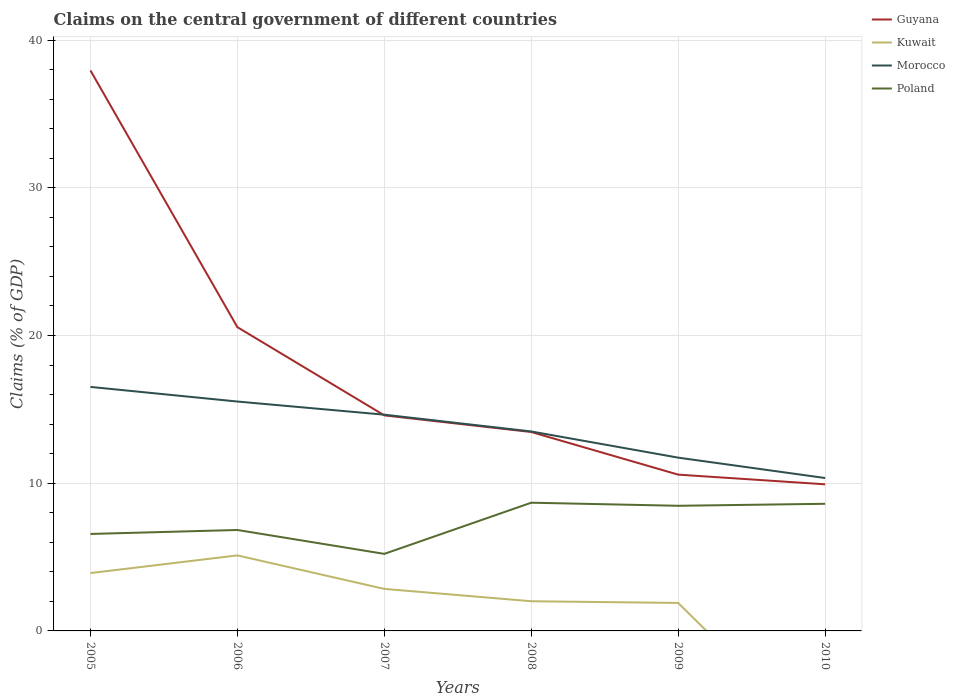Does the line corresponding to Poland intersect with the line corresponding to Guyana?
Make the answer very short. No. Is the number of lines equal to the number of legend labels?
Keep it short and to the point. No. Across all years, what is the maximum percentage of GDP claimed on the central government in Kuwait?
Your answer should be compact. 0. What is the total percentage of GDP claimed on the central government in Poland in the graph?
Provide a succinct answer. -2.04. What is the difference between the highest and the second highest percentage of GDP claimed on the central government in Morocco?
Give a very brief answer. 6.17. What is the difference between the highest and the lowest percentage of GDP claimed on the central government in Poland?
Give a very brief answer. 3. How many years are there in the graph?
Provide a succinct answer. 6. What is the difference between two consecutive major ticks on the Y-axis?
Give a very brief answer. 10. Are the values on the major ticks of Y-axis written in scientific E-notation?
Your response must be concise. No. Does the graph contain any zero values?
Your response must be concise. Yes. Does the graph contain grids?
Your answer should be very brief. Yes. Where does the legend appear in the graph?
Your answer should be very brief. Top right. What is the title of the graph?
Your answer should be compact. Claims on the central government of different countries. What is the label or title of the X-axis?
Offer a very short reply. Years. What is the label or title of the Y-axis?
Offer a very short reply. Claims (% of GDP). What is the Claims (% of GDP) in Guyana in 2005?
Offer a terse response. 37.94. What is the Claims (% of GDP) in Kuwait in 2005?
Your response must be concise. 3.92. What is the Claims (% of GDP) of Morocco in 2005?
Provide a short and direct response. 16.52. What is the Claims (% of GDP) of Poland in 2005?
Provide a succinct answer. 6.56. What is the Claims (% of GDP) of Guyana in 2006?
Make the answer very short. 20.56. What is the Claims (% of GDP) in Kuwait in 2006?
Give a very brief answer. 5.11. What is the Claims (% of GDP) of Morocco in 2006?
Provide a short and direct response. 15.53. What is the Claims (% of GDP) in Poland in 2006?
Your answer should be compact. 6.83. What is the Claims (% of GDP) of Guyana in 2007?
Keep it short and to the point. 14.59. What is the Claims (% of GDP) of Kuwait in 2007?
Your answer should be very brief. 2.84. What is the Claims (% of GDP) of Morocco in 2007?
Keep it short and to the point. 14.64. What is the Claims (% of GDP) of Poland in 2007?
Ensure brevity in your answer.  5.22. What is the Claims (% of GDP) of Guyana in 2008?
Ensure brevity in your answer.  13.47. What is the Claims (% of GDP) in Kuwait in 2008?
Ensure brevity in your answer.  2.01. What is the Claims (% of GDP) of Morocco in 2008?
Your answer should be compact. 13.5. What is the Claims (% of GDP) of Poland in 2008?
Your response must be concise. 8.68. What is the Claims (% of GDP) in Guyana in 2009?
Keep it short and to the point. 10.58. What is the Claims (% of GDP) in Kuwait in 2009?
Your answer should be very brief. 1.89. What is the Claims (% of GDP) of Morocco in 2009?
Provide a short and direct response. 11.73. What is the Claims (% of GDP) in Poland in 2009?
Give a very brief answer. 8.47. What is the Claims (% of GDP) of Guyana in 2010?
Give a very brief answer. 9.93. What is the Claims (% of GDP) in Morocco in 2010?
Make the answer very short. 10.35. What is the Claims (% of GDP) of Poland in 2010?
Your answer should be compact. 8.61. Across all years, what is the maximum Claims (% of GDP) in Guyana?
Your answer should be compact. 37.94. Across all years, what is the maximum Claims (% of GDP) in Kuwait?
Provide a succinct answer. 5.11. Across all years, what is the maximum Claims (% of GDP) of Morocco?
Offer a very short reply. 16.52. Across all years, what is the maximum Claims (% of GDP) in Poland?
Your response must be concise. 8.68. Across all years, what is the minimum Claims (% of GDP) in Guyana?
Give a very brief answer. 9.93. Across all years, what is the minimum Claims (% of GDP) in Kuwait?
Ensure brevity in your answer.  0. Across all years, what is the minimum Claims (% of GDP) in Morocco?
Provide a short and direct response. 10.35. Across all years, what is the minimum Claims (% of GDP) of Poland?
Keep it short and to the point. 5.22. What is the total Claims (% of GDP) of Guyana in the graph?
Provide a short and direct response. 107.07. What is the total Claims (% of GDP) of Kuwait in the graph?
Provide a succinct answer. 15.78. What is the total Claims (% of GDP) in Morocco in the graph?
Your response must be concise. 82.27. What is the total Claims (% of GDP) in Poland in the graph?
Ensure brevity in your answer.  44.37. What is the difference between the Claims (% of GDP) of Guyana in 2005 and that in 2006?
Provide a succinct answer. 17.38. What is the difference between the Claims (% of GDP) of Kuwait in 2005 and that in 2006?
Offer a terse response. -1.2. What is the difference between the Claims (% of GDP) of Morocco in 2005 and that in 2006?
Provide a succinct answer. 0.99. What is the difference between the Claims (% of GDP) in Poland in 2005 and that in 2006?
Provide a short and direct response. -0.27. What is the difference between the Claims (% of GDP) in Guyana in 2005 and that in 2007?
Your answer should be compact. 23.35. What is the difference between the Claims (% of GDP) of Kuwait in 2005 and that in 2007?
Provide a succinct answer. 1.07. What is the difference between the Claims (% of GDP) of Morocco in 2005 and that in 2007?
Provide a short and direct response. 1.88. What is the difference between the Claims (% of GDP) in Poland in 2005 and that in 2007?
Make the answer very short. 1.35. What is the difference between the Claims (% of GDP) in Guyana in 2005 and that in 2008?
Keep it short and to the point. 24.48. What is the difference between the Claims (% of GDP) in Kuwait in 2005 and that in 2008?
Your answer should be compact. 1.91. What is the difference between the Claims (% of GDP) in Morocco in 2005 and that in 2008?
Provide a succinct answer. 3.02. What is the difference between the Claims (% of GDP) in Poland in 2005 and that in 2008?
Give a very brief answer. -2.12. What is the difference between the Claims (% of GDP) of Guyana in 2005 and that in 2009?
Make the answer very short. 27.36. What is the difference between the Claims (% of GDP) of Kuwait in 2005 and that in 2009?
Provide a succinct answer. 2.02. What is the difference between the Claims (% of GDP) in Morocco in 2005 and that in 2009?
Your response must be concise. 4.79. What is the difference between the Claims (% of GDP) in Poland in 2005 and that in 2009?
Your answer should be compact. -1.91. What is the difference between the Claims (% of GDP) in Guyana in 2005 and that in 2010?
Your response must be concise. 28.02. What is the difference between the Claims (% of GDP) in Morocco in 2005 and that in 2010?
Ensure brevity in your answer.  6.17. What is the difference between the Claims (% of GDP) of Poland in 2005 and that in 2010?
Make the answer very short. -2.04. What is the difference between the Claims (% of GDP) of Guyana in 2006 and that in 2007?
Provide a succinct answer. 5.97. What is the difference between the Claims (% of GDP) of Kuwait in 2006 and that in 2007?
Ensure brevity in your answer.  2.27. What is the difference between the Claims (% of GDP) in Morocco in 2006 and that in 2007?
Keep it short and to the point. 0.89. What is the difference between the Claims (% of GDP) of Poland in 2006 and that in 2007?
Make the answer very short. 1.62. What is the difference between the Claims (% of GDP) of Guyana in 2006 and that in 2008?
Offer a terse response. 7.1. What is the difference between the Claims (% of GDP) in Kuwait in 2006 and that in 2008?
Provide a succinct answer. 3.1. What is the difference between the Claims (% of GDP) of Morocco in 2006 and that in 2008?
Your answer should be very brief. 2.03. What is the difference between the Claims (% of GDP) in Poland in 2006 and that in 2008?
Provide a short and direct response. -1.85. What is the difference between the Claims (% of GDP) in Guyana in 2006 and that in 2009?
Provide a succinct answer. 9.98. What is the difference between the Claims (% of GDP) in Kuwait in 2006 and that in 2009?
Offer a terse response. 3.22. What is the difference between the Claims (% of GDP) of Morocco in 2006 and that in 2009?
Give a very brief answer. 3.8. What is the difference between the Claims (% of GDP) in Poland in 2006 and that in 2009?
Offer a terse response. -1.64. What is the difference between the Claims (% of GDP) in Guyana in 2006 and that in 2010?
Keep it short and to the point. 10.64. What is the difference between the Claims (% of GDP) of Morocco in 2006 and that in 2010?
Provide a short and direct response. 5.18. What is the difference between the Claims (% of GDP) of Poland in 2006 and that in 2010?
Your answer should be very brief. -1.77. What is the difference between the Claims (% of GDP) of Guyana in 2007 and that in 2008?
Keep it short and to the point. 1.13. What is the difference between the Claims (% of GDP) of Kuwait in 2007 and that in 2008?
Your response must be concise. 0.84. What is the difference between the Claims (% of GDP) of Morocco in 2007 and that in 2008?
Offer a terse response. 1.14. What is the difference between the Claims (% of GDP) in Poland in 2007 and that in 2008?
Make the answer very short. -3.46. What is the difference between the Claims (% of GDP) of Guyana in 2007 and that in 2009?
Your answer should be very brief. 4.01. What is the difference between the Claims (% of GDP) in Kuwait in 2007 and that in 2009?
Offer a very short reply. 0.95. What is the difference between the Claims (% of GDP) in Morocco in 2007 and that in 2009?
Your answer should be very brief. 2.91. What is the difference between the Claims (% of GDP) of Poland in 2007 and that in 2009?
Keep it short and to the point. -3.26. What is the difference between the Claims (% of GDP) of Guyana in 2007 and that in 2010?
Keep it short and to the point. 4.67. What is the difference between the Claims (% of GDP) of Morocco in 2007 and that in 2010?
Keep it short and to the point. 4.29. What is the difference between the Claims (% of GDP) in Poland in 2007 and that in 2010?
Give a very brief answer. -3.39. What is the difference between the Claims (% of GDP) of Guyana in 2008 and that in 2009?
Provide a short and direct response. 2.89. What is the difference between the Claims (% of GDP) in Kuwait in 2008 and that in 2009?
Provide a short and direct response. 0.11. What is the difference between the Claims (% of GDP) of Morocco in 2008 and that in 2009?
Offer a very short reply. 1.77. What is the difference between the Claims (% of GDP) in Poland in 2008 and that in 2009?
Ensure brevity in your answer.  0.21. What is the difference between the Claims (% of GDP) in Guyana in 2008 and that in 2010?
Provide a succinct answer. 3.54. What is the difference between the Claims (% of GDP) of Morocco in 2008 and that in 2010?
Give a very brief answer. 3.15. What is the difference between the Claims (% of GDP) of Poland in 2008 and that in 2010?
Provide a succinct answer. 0.07. What is the difference between the Claims (% of GDP) in Guyana in 2009 and that in 2010?
Make the answer very short. 0.65. What is the difference between the Claims (% of GDP) of Morocco in 2009 and that in 2010?
Provide a succinct answer. 1.38. What is the difference between the Claims (% of GDP) of Poland in 2009 and that in 2010?
Your answer should be very brief. -0.13. What is the difference between the Claims (% of GDP) in Guyana in 2005 and the Claims (% of GDP) in Kuwait in 2006?
Keep it short and to the point. 32.83. What is the difference between the Claims (% of GDP) of Guyana in 2005 and the Claims (% of GDP) of Morocco in 2006?
Offer a very short reply. 22.41. What is the difference between the Claims (% of GDP) of Guyana in 2005 and the Claims (% of GDP) of Poland in 2006?
Give a very brief answer. 31.11. What is the difference between the Claims (% of GDP) of Kuwait in 2005 and the Claims (% of GDP) of Morocco in 2006?
Provide a short and direct response. -11.61. What is the difference between the Claims (% of GDP) in Kuwait in 2005 and the Claims (% of GDP) in Poland in 2006?
Your answer should be very brief. -2.92. What is the difference between the Claims (% of GDP) in Morocco in 2005 and the Claims (% of GDP) in Poland in 2006?
Provide a succinct answer. 9.69. What is the difference between the Claims (% of GDP) in Guyana in 2005 and the Claims (% of GDP) in Kuwait in 2007?
Your answer should be compact. 35.1. What is the difference between the Claims (% of GDP) in Guyana in 2005 and the Claims (% of GDP) in Morocco in 2007?
Your answer should be compact. 23.3. What is the difference between the Claims (% of GDP) of Guyana in 2005 and the Claims (% of GDP) of Poland in 2007?
Your answer should be very brief. 32.73. What is the difference between the Claims (% of GDP) in Kuwait in 2005 and the Claims (% of GDP) in Morocco in 2007?
Your answer should be compact. -10.72. What is the difference between the Claims (% of GDP) of Kuwait in 2005 and the Claims (% of GDP) of Poland in 2007?
Your answer should be very brief. -1.3. What is the difference between the Claims (% of GDP) in Morocco in 2005 and the Claims (% of GDP) in Poland in 2007?
Give a very brief answer. 11.3. What is the difference between the Claims (% of GDP) of Guyana in 2005 and the Claims (% of GDP) of Kuwait in 2008?
Offer a very short reply. 35.93. What is the difference between the Claims (% of GDP) of Guyana in 2005 and the Claims (% of GDP) of Morocco in 2008?
Offer a very short reply. 24.44. What is the difference between the Claims (% of GDP) of Guyana in 2005 and the Claims (% of GDP) of Poland in 2008?
Provide a succinct answer. 29.26. What is the difference between the Claims (% of GDP) in Kuwait in 2005 and the Claims (% of GDP) in Morocco in 2008?
Your response must be concise. -9.59. What is the difference between the Claims (% of GDP) in Kuwait in 2005 and the Claims (% of GDP) in Poland in 2008?
Your response must be concise. -4.76. What is the difference between the Claims (% of GDP) in Morocco in 2005 and the Claims (% of GDP) in Poland in 2008?
Make the answer very short. 7.84. What is the difference between the Claims (% of GDP) in Guyana in 2005 and the Claims (% of GDP) in Kuwait in 2009?
Offer a very short reply. 36.05. What is the difference between the Claims (% of GDP) of Guyana in 2005 and the Claims (% of GDP) of Morocco in 2009?
Your answer should be very brief. 26.21. What is the difference between the Claims (% of GDP) of Guyana in 2005 and the Claims (% of GDP) of Poland in 2009?
Ensure brevity in your answer.  29.47. What is the difference between the Claims (% of GDP) in Kuwait in 2005 and the Claims (% of GDP) in Morocco in 2009?
Provide a short and direct response. -7.81. What is the difference between the Claims (% of GDP) in Kuwait in 2005 and the Claims (% of GDP) in Poland in 2009?
Your answer should be very brief. -4.56. What is the difference between the Claims (% of GDP) in Morocco in 2005 and the Claims (% of GDP) in Poland in 2009?
Offer a terse response. 8.05. What is the difference between the Claims (% of GDP) of Guyana in 2005 and the Claims (% of GDP) of Morocco in 2010?
Keep it short and to the point. 27.59. What is the difference between the Claims (% of GDP) of Guyana in 2005 and the Claims (% of GDP) of Poland in 2010?
Your answer should be very brief. 29.34. What is the difference between the Claims (% of GDP) of Kuwait in 2005 and the Claims (% of GDP) of Morocco in 2010?
Provide a succinct answer. -6.44. What is the difference between the Claims (% of GDP) in Kuwait in 2005 and the Claims (% of GDP) in Poland in 2010?
Keep it short and to the point. -4.69. What is the difference between the Claims (% of GDP) of Morocco in 2005 and the Claims (% of GDP) of Poland in 2010?
Give a very brief answer. 7.91. What is the difference between the Claims (% of GDP) in Guyana in 2006 and the Claims (% of GDP) in Kuwait in 2007?
Ensure brevity in your answer.  17.72. What is the difference between the Claims (% of GDP) in Guyana in 2006 and the Claims (% of GDP) in Morocco in 2007?
Your answer should be very brief. 5.92. What is the difference between the Claims (% of GDP) in Guyana in 2006 and the Claims (% of GDP) in Poland in 2007?
Provide a short and direct response. 15.35. What is the difference between the Claims (% of GDP) in Kuwait in 2006 and the Claims (% of GDP) in Morocco in 2007?
Offer a very short reply. -9.53. What is the difference between the Claims (% of GDP) in Kuwait in 2006 and the Claims (% of GDP) in Poland in 2007?
Your response must be concise. -0.1. What is the difference between the Claims (% of GDP) in Morocco in 2006 and the Claims (% of GDP) in Poland in 2007?
Ensure brevity in your answer.  10.31. What is the difference between the Claims (% of GDP) of Guyana in 2006 and the Claims (% of GDP) of Kuwait in 2008?
Ensure brevity in your answer.  18.55. What is the difference between the Claims (% of GDP) in Guyana in 2006 and the Claims (% of GDP) in Morocco in 2008?
Keep it short and to the point. 7.06. What is the difference between the Claims (% of GDP) of Guyana in 2006 and the Claims (% of GDP) of Poland in 2008?
Provide a short and direct response. 11.88. What is the difference between the Claims (% of GDP) of Kuwait in 2006 and the Claims (% of GDP) of Morocco in 2008?
Ensure brevity in your answer.  -8.39. What is the difference between the Claims (% of GDP) in Kuwait in 2006 and the Claims (% of GDP) in Poland in 2008?
Your answer should be compact. -3.57. What is the difference between the Claims (% of GDP) of Morocco in 2006 and the Claims (% of GDP) of Poland in 2008?
Your answer should be very brief. 6.85. What is the difference between the Claims (% of GDP) in Guyana in 2006 and the Claims (% of GDP) in Kuwait in 2009?
Your answer should be very brief. 18.67. What is the difference between the Claims (% of GDP) of Guyana in 2006 and the Claims (% of GDP) of Morocco in 2009?
Make the answer very short. 8.83. What is the difference between the Claims (% of GDP) of Guyana in 2006 and the Claims (% of GDP) of Poland in 2009?
Keep it short and to the point. 12.09. What is the difference between the Claims (% of GDP) in Kuwait in 2006 and the Claims (% of GDP) in Morocco in 2009?
Make the answer very short. -6.62. What is the difference between the Claims (% of GDP) in Kuwait in 2006 and the Claims (% of GDP) in Poland in 2009?
Your answer should be very brief. -3.36. What is the difference between the Claims (% of GDP) of Morocco in 2006 and the Claims (% of GDP) of Poland in 2009?
Ensure brevity in your answer.  7.06. What is the difference between the Claims (% of GDP) in Guyana in 2006 and the Claims (% of GDP) in Morocco in 2010?
Give a very brief answer. 10.21. What is the difference between the Claims (% of GDP) of Guyana in 2006 and the Claims (% of GDP) of Poland in 2010?
Provide a succinct answer. 11.96. What is the difference between the Claims (% of GDP) of Kuwait in 2006 and the Claims (% of GDP) of Morocco in 2010?
Provide a short and direct response. -5.24. What is the difference between the Claims (% of GDP) in Kuwait in 2006 and the Claims (% of GDP) in Poland in 2010?
Offer a terse response. -3.49. What is the difference between the Claims (% of GDP) in Morocco in 2006 and the Claims (% of GDP) in Poland in 2010?
Make the answer very short. 6.92. What is the difference between the Claims (% of GDP) in Guyana in 2007 and the Claims (% of GDP) in Kuwait in 2008?
Offer a very short reply. 12.58. What is the difference between the Claims (% of GDP) of Guyana in 2007 and the Claims (% of GDP) of Morocco in 2008?
Offer a terse response. 1.09. What is the difference between the Claims (% of GDP) of Guyana in 2007 and the Claims (% of GDP) of Poland in 2008?
Your response must be concise. 5.91. What is the difference between the Claims (% of GDP) in Kuwait in 2007 and the Claims (% of GDP) in Morocco in 2008?
Ensure brevity in your answer.  -10.66. What is the difference between the Claims (% of GDP) of Kuwait in 2007 and the Claims (% of GDP) of Poland in 2008?
Provide a short and direct response. -5.83. What is the difference between the Claims (% of GDP) in Morocco in 2007 and the Claims (% of GDP) in Poland in 2008?
Your answer should be compact. 5.96. What is the difference between the Claims (% of GDP) of Guyana in 2007 and the Claims (% of GDP) of Kuwait in 2009?
Provide a succinct answer. 12.7. What is the difference between the Claims (% of GDP) in Guyana in 2007 and the Claims (% of GDP) in Morocco in 2009?
Your response must be concise. 2.86. What is the difference between the Claims (% of GDP) in Guyana in 2007 and the Claims (% of GDP) in Poland in 2009?
Your answer should be very brief. 6.12. What is the difference between the Claims (% of GDP) of Kuwait in 2007 and the Claims (% of GDP) of Morocco in 2009?
Your response must be concise. -8.89. What is the difference between the Claims (% of GDP) in Kuwait in 2007 and the Claims (% of GDP) in Poland in 2009?
Give a very brief answer. -5.63. What is the difference between the Claims (% of GDP) in Morocco in 2007 and the Claims (% of GDP) in Poland in 2009?
Offer a terse response. 6.17. What is the difference between the Claims (% of GDP) of Guyana in 2007 and the Claims (% of GDP) of Morocco in 2010?
Provide a short and direct response. 4.24. What is the difference between the Claims (% of GDP) in Guyana in 2007 and the Claims (% of GDP) in Poland in 2010?
Offer a terse response. 5.99. What is the difference between the Claims (% of GDP) of Kuwait in 2007 and the Claims (% of GDP) of Morocco in 2010?
Make the answer very short. -7.51. What is the difference between the Claims (% of GDP) of Kuwait in 2007 and the Claims (% of GDP) of Poland in 2010?
Give a very brief answer. -5.76. What is the difference between the Claims (% of GDP) of Morocco in 2007 and the Claims (% of GDP) of Poland in 2010?
Your answer should be very brief. 6.03. What is the difference between the Claims (% of GDP) of Guyana in 2008 and the Claims (% of GDP) of Kuwait in 2009?
Your answer should be very brief. 11.57. What is the difference between the Claims (% of GDP) of Guyana in 2008 and the Claims (% of GDP) of Morocco in 2009?
Keep it short and to the point. 1.74. What is the difference between the Claims (% of GDP) in Guyana in 2008 and the Claims (% of GDP) in Poland in 2009?
Offer a terse response. 5. What is the difference between the Claims (% of GDP) of Kuwait in 2008 and the Claims (% of GDP) of Morocco in 2009?
Make the answer very short. -9.72. What is the difference between the Claims (% of GDP) in Kuwait in 2008 and the Claims (% of GDP) in Poland in 2009?
Provide a short and direct response. -6.46. What is the difference between the Claims (% of GDP) of Morocco in 2008 and the Claims (% of GDP) of Poland in 2009?
Give a very brief answer. 5.03. What is the difference between the Claims (% of GDP) of Guyana in 2008 and the Claims (% of GDP) of Morocco in 2010?
Provide a succinct answer. 3.12. What is the difference between the Claims (% of GDP) in Guyana in 2008 and the Claims (% of GDP) in Poland in 2010?
Make the answer very short. 4.86. What is the difference between the Claims (% of GDP) of Kuwait in 2008 and the Claims (% of GDP) of Morocco in 2010?
Offer a very short reply. -8.34. What is the difference between the Claims (% of GDP) of Kuwait in 2008 and the Claims (% of GDP) of Poland in 2010?
Provide a succinct answer. -6.6. What is the difference between the Claims (% of GDP) of Morocco in 2008 and the Claims (% of GDP) of Poland in 2010?
Your answer should be very brief. 4.9. What is the difference between the Claims (% of GDP) of Guyana in 2009 and the Claims (% of GDP) of Morocco in 2010?
Provide a short and direct response. 0.23. What is the difference between the Claims (% of GDP) of Guyana in 2009 and the Claims (% of GDP) of Poland in 2010?
Provide a succinct answer. 1.97. What is the difference between the Claims (% of GDP) of Kuwait in 2009 and the Claims (% of GDP) of Morocco in 2010?
Provide a short and direct response. -8.46. What is the difference between the Claims (% of GDP) of Kuwait in 2009 and the Claims (% of GDP) of Poland in 2010?
Offer a terse response. -6.71. What is the difference between the Claims (% of GDP) of Morocco in 2009 and the Claims (% of GDP) of Poland in 2010?
Keep it short and to the point. 3.12. What is the average Claims (% of GDP) of Guyana per year?
Your answer should be very brief. 17.84. What is the average Claims (% of GDP) of Kuwait per year?
Your answer should be very brief. 2.63. What is the average Claims (% of GDP) of Morocco per year?
Your response must be concise. 13.71. What is the average Claims (% of GDP) of Poland per year?
Your answer should be compact. 7.39. In the year 2005, what is the difference between the Claims (% of GDP) of Guyana and Claims (% of GDP) of Kuwait?
Your answer should be very brief. 34.03. In the year 2005, what is the difference between the Claims (% of GDP) of Guyana and Claims (% of GDP) of Morocco?
Offer a very short reply. 21.42. In the year 2005, what is the difference between the Claims (% of GDP) in Guyana and Claims (% of GDP) in Poland?
Keep it short and to the point. 31.38. In the year 2005, what is the difference between the Claims (% of GDP) of Kuwait and Claims (% of GDP) of Morocco?
Make the answer very short. -12.6. In the year 2005, what is the difference between the Claims (% of GDP) of Kuwait and Claims (% of GDP) of Poland?
Your answer should be very brief. -2.65. In the year 2005, what is the difference between the Claims (% of GDP) in Morocco and Claims (% of GDP) in Poland?
Give a very brief answer. 9.95. In the year 2006, what is the difference between the Claims (% of GDP) in Guyana and Claims (% of GDP) in Kuwait?
Make the answer very short. 15.45. In the year 2006, what is the difference between the Claims (% of GDP) in Guyana and Claims (% of GDP) in Morocco?
Your answer should be very brief. 5.04. In the year 2006, what is the difference between the Claims (% of GDP) of Guyana and Claims (% of GDP) of Poland?
Offer a terse response. 13.73. In the year 2006, what is the difference between the Claims (% of GDP) of Kuwait and Claims (% of GDP) of Morocco?
Provide a succinct answer. -10.42. In the year 2006, what is the difference between the Claims (% of GDP) of Kuwait and Claims (% of GDP) of Poland?
Your response must be concise. -1.72. In the year 2006, what is the difference between the Claims (% of GDP) in Morocco and Claims (% of GDP) in Poland?
Keep it short and to the point. 8.7. In the year 2007, what is the difference between the Claims (% of GDP) in Guyana and Claims (% of GDP) in Kuwait?
Keep it short and to the point. 11.75. In the year 2007, what is the difference between the Claims (% of GDP) in Guyana and Claims (% of GDP) in Morocco?
Offer a very short reply. -0.05. In the year 2007, what is the difference between the Claims (% of GDP) of Guyana and Claims (% of GDP) of Poland?
Provide a short and direct response. 9.38. In the year 2007, what is the difference between the Claims (% of GDP) in Kuwait and Claims (% of GDP) in Morocco?
Offer a very short reply. -11.79. In the year 2007, what is the difference between the Claims (% of GDP) of Kuwait and Claims (% of GDP) of Poland?
Give a very brief answer. -2.37. In the year 2007, what is the difference between the Claims (% of GDP) in Morocco and Claims (% of GDP) in Poland?
Provide a short and direct response. 9.42. In the year 2008, what is the difference between the Claims (% of GDP) of Guyana and Claims (% of GDP) of Kuwait?
Your response must be concise. 11.46. In the year 2008, what is the difference between the Claims (% of GDP) of Guyana and Claims (% of GDP) of Morocco?
Make the answer very short. -0.04. In the year 2008, what is the difference between the Claims (% of GDP) of Guyana and Claims (% of GDP) of Poland?
Provide a short and direct response. 4.79. In the year 2008, what is the difference between the Claims (% of GDP) of Kuwait and Claims (% of GDP) of Morocco?
Your response must be concise. -11.49. In the year 2008, what is the difference between the Claims (% of GDP) in Kuwait and Claims (% of GDP) in Poland?
Provide a short and direct response. -6.67. In the year 2008, what is the difference between the Claims (% of GDP) of Morocco and Claims (% of GDP) of Poland?
Give a very brief answer. 4.82. In the year 2009, what is the difference between the Claims (% of GDP) in Guyana and Claims (% of GDP) in Kuwait?
Your answer should be compact. 8.69. In the year 2009, what is the difference between the Claims (% of GDP) in Guyana and Claims (% of GDP) in Morocco?
Your response must be concise. -1.15. In the year 2009, what is the difference between the Claims (% of GDP) of Guyana and Claims (% of GDP) of Poland?
Make the answer very short. 2.11. In the year 2009, what is the difference between the Claims (% of GDP) of Kuwait and Claims (% of GDP) of Morocco?
Provide a short and direct response. -9.84. In the year 2009, what is the difference between the Claims (% of GDP) of Kuwait and Claims (% of GDP) of Poland?
Offer a very short reply. -6.58. In the year 2009, what is the difference between the Claims (% of GDP) in Morocco and Claims (% of GDP) in Poland?
Provide a short and direct response. 3.26. In the year 2010, what is the difference between the Claims (% of GDP) in Guyana and Claims (% of GDP) in Morocco?
Your answer should be very brief. -0.43. In the year 2010, what is the difference between the Claims (% of GDP) in Guyana and Claims (% of GDP) in Poland?
Ensure brevity in your answer.  1.32. In the year 2010, what is the difference between the Claims (% of GDP) in Morocco and Claims (% of GDP) in Poland?
Make the answer very short. 1.75. What is the ratio of the Claims (% of GDP) in Guyana in 2005 to that in 2006?
Your response must be concise. 1.84. What is the ratio of the Claims (% of GDP) in Kuwait in 2005 to that in 2006?
Your response must be concise. 0.77. What is the ratio of the Claims (% of GDP) of Morocco in 2005 to that in 2006?
Offer a very short reply. 1.06. What is the ratio of the Claims (% of GDP) in Poland in 2005 to that in 2006?
Keep it short and to the point. 0.96. What is the ratio of the Claims (% of GDP) in Guyana in 2005 to that in 2007?
Your answer should be compact. 2.6. What is the ratio of the Claims (% of GDP) of Kuwait in 2005 to that in 2007?
Provide a succinct answer. 1.38. What is the ratio of the Claims (% of GDP) in Morocco in 2005 to that in 2007?
Offer a very short reply. 1.13. What is the ratio of the Claims (% of GDP) in Poland in 2005 to that in 2007?
Your response must be concise. 1.26. What is the ratio of the Claims (% of GDP) of Guyana in 2005 to that in 2008?
Make the answer very short. 2.82. What is the ratio of the Claims (% of GDP) of Kuwait in 2005 to that in 2008?
Provide a succinct answer. 1.95. What is the ratio of the Claims (% of GDP) of Morocco in 2005 to that in 2008?
Provide a short and direct response. 1.22. What is the ratio of the Claims (% of GDP) of Poland in 2005 to that in 2008?
Make the answer very short. 0.76. What is the ratio of the Claims (% of GDP) of Guyana in 2005 to that in 2009?
Offer a very short reply. 3.59. What is the ratio of the Claims (% of GDP) of Kuwait in 2005 to that in 2009?
Offer a very short reply. 2.07. What is the ratio of the Claims (% of GDP) in Morocco in 2005 to that in 2009?
Keep it short and to the point. 1.41. What is the ratio of the Claims (% of GDP) in Poland in 2005 to that in 2009?
Your response must be concise. 0.77. What is the ratio of the Claims (% of GDP) of Guyana in 2005 to that in 2010?
Make the answer very short. 3.82. What is the ratio of the Claims (% of GDP) of Morocco in 2005 to that in 2010?
Make the answer very short. 1.6. What is the ratio of the Claims (% of GDP) of Poland in 2005 to that in 2010?
Ensure brevity in your answer.  0.76. What is the ratio of the Claims (% of GDP) in Guyana in 2006 to that in 2007?
Give a very brief answer. 1.41. What is the ratio of the Claims (% of GDP) of Kuwait in 2006 to that in 2007?
Offer a very short reply. 1.8. What is the ratio of the Claims (% of GDP) of Morocco in 2006 to that in 2007?
Your answer should be compact. 1.06. What is the ratio of the Claims (% of GDP) of Poland in 2006 to that in 2007?
Ensure brevity in your answer.  1.31. What is the ratio of the Claims (% of GDP) in Guyana in 2006 to that in 2008?
Offer a terse response. 1.53. What is the ratio of the Claims (% of GDP) in Kuwait in 2006 to that in 2008?
Your answer should be very brief. 2.54. What is the ratio of the Claims (% of GDP) in Morocco in 2006 to that in 2008?
Keep it short and to the point. 1.15. What is the ratio of the Claims (% of GDP) in Poland in 2006 to that in 2008?
Provide a short and direct response. 0.79. What is the ratio of the Claims (% of GDP) of Guyana in 2006 to that in 2009?
Provide a succinct answer. 1.94. What is the ratio of the Claims (% of GDP) in Kuwait in 2006 to that in 2009?
Offer a terse response. 2.7. What is the ratio of the Claims (% of GDP) in Morocco in 2006 to that in 2009?
Give a very brief answer. 1.32. What is the ratio of the Claims (% of GDP) of Poland in 2006 to that in 2009?
Make the answer very short. 0.81. What is the ratio of the Claims (% of GDP) in Guyana in 2006 to that in 2010?
Your response must be concise. 2.07. What is the ratio of the Claims (% of GDP) in Morocco in 2006 to that in 2010?
Offer a very short reply. 1.5. What is the ratio of the Claims (% of GDP) in Poland in 2006 to that in 2010?
Offer a terse response. 0.79. What is the ratio of the Claims (% of GDP) of Guyana in 2007 to that in 2008?
Your answer should be very brief. 1.08. What is the ratio of the Claims (% of GDP) of Kuwait in 2007 to that in 2008?
Provide a short and direct response. 1.42. What is the ratio of the Claims (% of GDP) in Morocco in 2007 to that in 2008?
Offer a very short reply. 1.08. What is the ratio of the Claims (% of GDP) of Poland in 2007 to that in 2008?
Ensure brevity in your answer.  0.6. What is the ratio of the Claims (% of GDP) in Guyana in 2007 to that in 2009?
Your answer should be compact. 1.38. What is the ratio of the Claims (% of GDP) of Kuwait in 2007 to that in 2009?
Offer a very short reply. 1.5. What is the ratio of the Claims (% of GDP) in Morocco in 2007 to that in 2009?
Your answer should be compact. 1.25. What is the ratio of the Claims (% of GDP) of Poland in 2007 to that in 2009?
Offer a very short reply. 0.62. What is the ratio of the Claims (% of GDP) in Guyana in 2007 to that in 2010?
Offer a terse response. 1.47. What is the ratio of the Claims (% of GDP) in Morocco in 2007 to that in 2010?
Offer a very short reply. 1.41. What is the ratio of the Claims (% of GDP) in Poland in 2007 to that in 2010?
Offer a terse response. 0.61. What is the ratio of the Claims (% of GDP) of Guyana in 2008 to that in 2009?
Make the answer very short. 1.27. What is the ratio of the Claims (% of GDP) of Kuwait in 2008 to that in 2009?
Offer a terse response. 1.06. What is the ratio of the Claims (% of GDP) in Morocco in 2008 to that in 2009?
Provide a short and direct response. 1.15. What is the ratio of the Claims (% of GDP) of Poland in 2008 to that in 2009?
Provide a short and direct response. 1.02. What is the ratio of the Claims (% of GDP) in Guyana in 2008 to that in 2010?
Provide a short and direct response. 1.36. What is the ratio of the Claims (% of GDP) in Morocco in 2008 to that in 2010?
Provide a succinct answer. 1.3. What is the ratio of the Claims (% of GDP) in Poland in 2008 to that in 2010?
Offer a terse response. 1.01. What is the ratio of the Claims (% of GDP) of Guyana in 2009 to that in 2010?
Your answer should be compact. 1.07. What is the ratio of the Claims (% of GDP) in Morocco in 2009 to that in 2010?
Make the answer very short. 1.13. What is the ratio of the Claims (% of GDP) in Poland in 2009 to that in 2010?
Give a very brief answer. 0.98. What is the difference between the highest and the second highest Claims (% of GDP) in Guyana?
Ensure brevity in your answer.  17.38. What is the difference between the highest and the second highest Claims (% of GDP) of Kuwait?
Your response must be concise. 1.2. What is the difference between the highest and the second highest Claims (% of GDP) in Morocco?
Offer a terse response. 0.99. What is the difference between the highest and the second highest Claims (% of GDP) of Poland?
Ensure brevity in your answer.  0.07. What is the difference between the highest and the lowest Claims (% of GDP) of Guyana?
Make the answer very short. 28.02. What is the difference between the highest and the lowest Claims (% of GDP) in Kuwait?
Keep it short and to the point. 5.11. What is the difference between the highest and the lowest Claims (% of GDP) of Morocco?
Your answer should be compact. 6.17. What is the difference between the highest and the lowest Claims (% of GDP) of Poland?
Your answer should be very brief. 3.46. 